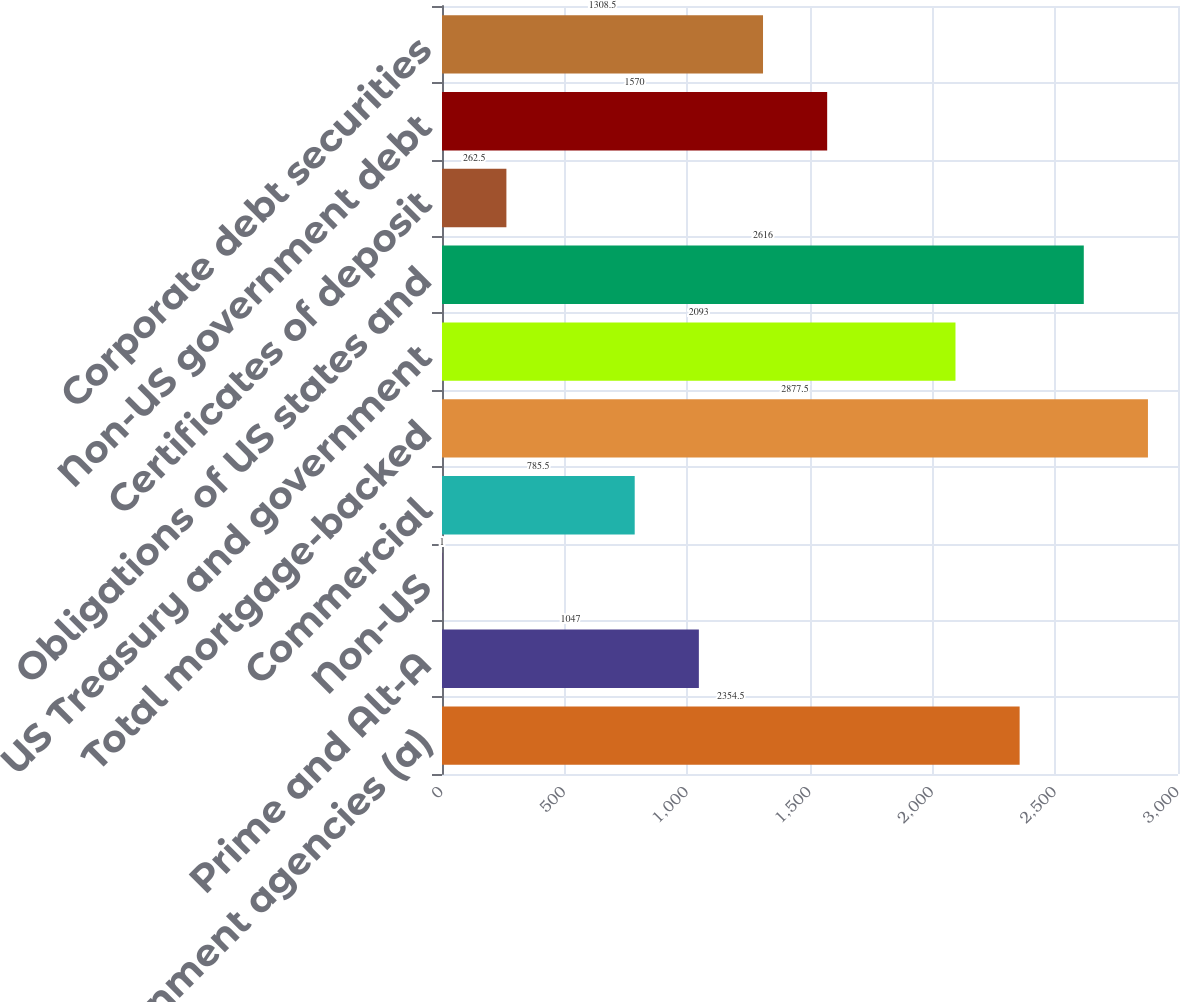Convert chart to OTSL. <chart><loc_0><loc_0><loc_500><loc_500><bar_chart><fcel>US government agencies (a)<fcel>Prime and Alt-A<fcel>Non-US<fcel>Commercial<fcel>Total mortgage-backed<fcel>US Treasury and government<fcel>Obligations of US states and<fcel>Certificates of deposit<fcel>Non-US government debt<fcel>Corporate debt securities<nl><fcel>2354.5<fcel>1047<fcel>1<fcel>785.5<fcel>2877.5<fcel>2093<fcel>2616<fcel>262.5<fcel>1570<fcel>1308.5<nl></chart> 